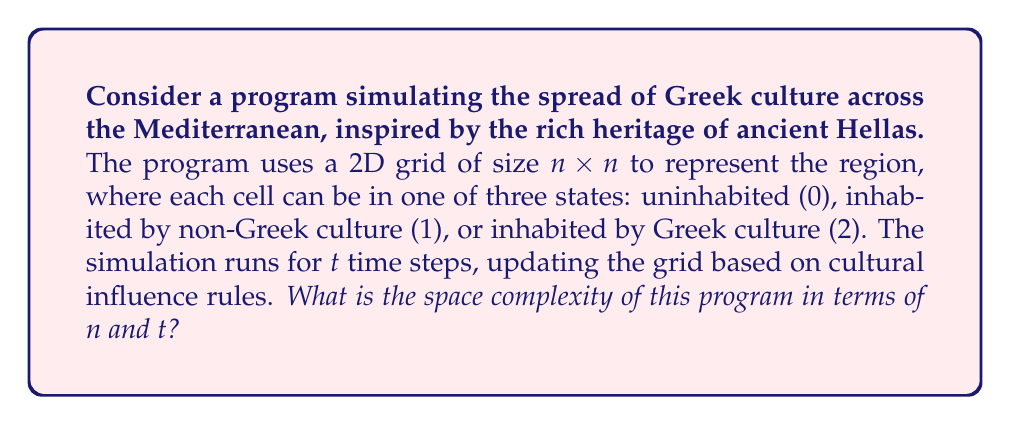What is the answer to this math problem? Let's analyze the space complexity step by step:

1. Grid representation:
   The main data structure is the 2D grid of size $n \times n$. Each cell requires 2 bits to represent the three possible states (00, 01, 10).
   Space required: $O(n^2)$ bits, or $O(n^2 / 8)$ bytes.

2. Time step storage:
   If we need to store the state of the grid at each time step for later analysis or visualization, we would need $t$ copies of the grid.
   Space required: $O(tn^2)$ bits, or $O(tn^2 / 8)$ bytes.

3. Additional variables:
   We may need some additional variables for the simulation, such as counters and temporary storage. These would typically require constant space, so we can represent them as $O(1)$.

4. Algorithm-specific data structures:
   Depending on the exact implementation of the cultural spread rules, we might need additional data structures. For example, a queue to store cells that need to be updated. In the worst case, this could be $O(n^2)$ if all cells need to be updated simultaneously.

5. Total space complexity:
   Combining all the above, we get:
   $O(tn^2 / 8 + n^2 / 8 + n^2 + 1)$ bytes

   Simplifying and using big-O notation, we can drop lower-order terms and constants:
   $O(tn^2 + n^2) = O(tn^2)$

However, if we don't need to store the grid state at each time step and only keep the current state, the space complexity reduces to:
$O(n^2)$

This more efficient implementation aligns with the resourcefulness often attributed to ancient Greek culture, making optimal use of available resources.
Answer: The space complexity is $O(tn^2)$ if storing all time steps, or $O(n^2)$ if only storing the current state. 